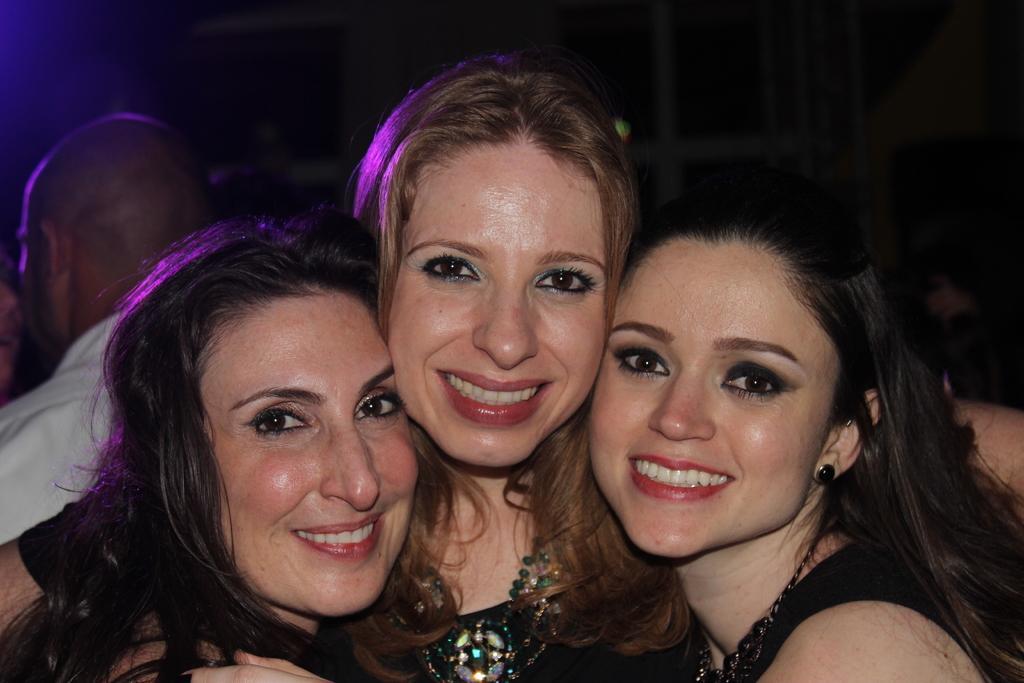Describe this image in one or two sentences. In this image we can see three ladies smiling. In the background we can see a person and it is dark. 